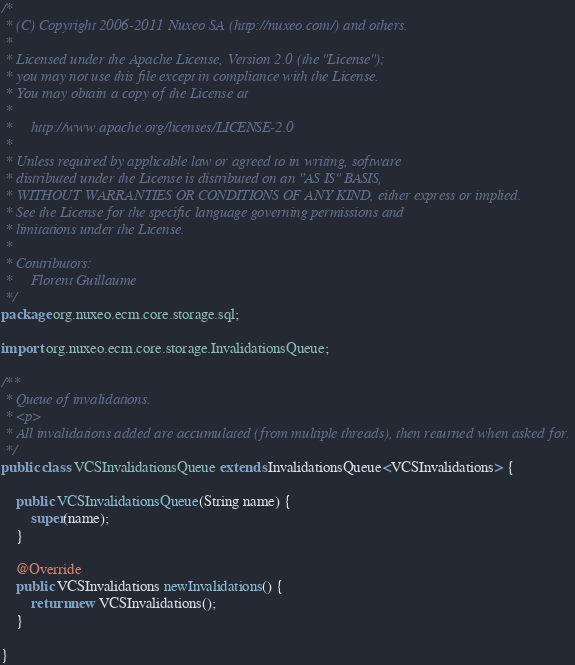<code> <loc_0><loc_0><loc_500><loc_500><_Java_>/*
 * (C) Copyright 2006-2011 Nuxeo SA (http://nuxeo.com/) and others.
 *
 * Licensed under the Apache License, Version 2.0 (the "License");
 * you may not use this file except in compliance with the License.
 * You may obtain a copy of the License at
 *
 *     http://www.apache.org/licenses/LICENSE-2.0
 *
 * Unless required by applicable law or agreed to in writing, software
 * distributed under the License is distributed on an "AS IS" BASIS,
 * WITHOUT WARRANTIES OR CONDITIONS OF ANY KIND, either express or implied.
 * See the License for the specific language governing permissions and
 * limitations under the License.
 *
 * Contributors:
 *     Florent Guillaume
 */
package org.nuxeo.ecm.core.storage.sql;

import org.nuxeo.ecm.core.storage.InvalidationsQueue;

/**
 * Queue of invalidations.
 * <p>
 * All invalidations added are accumulated (from multiple threads), then returned when asked for.
 */
public class VCSInvalidationsQueue extends InvalidationsQueue<VCSInvalidations> {

    public VCSInvalidationsQueue(String name) {
        super(name);
    }

    @Override
    public VCSInvalidations newInvalidations() {
        return new VCSInvalidations();
    }

}
</code> 